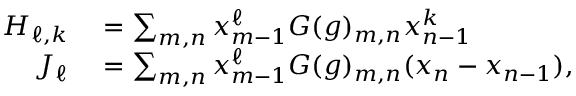<formula> <loc_0><loc_0><loc_500><loc_500>\begin{array} { r l } { H _ { \ell , k } } & = \sum _ { m , n } x _ { m - 1 } ^ { \ell } G ( g ) _ { m , n } x _ { n - 1 } ^ { k } } \\ { J _ { \ell } } & = \sum _ { m , n } x _ { m - 1 } ^ { \ell } G ( g ) _ { m , n } ( x _ { n } - x _ { n - 1 } ) , } \end{array}</formula> 